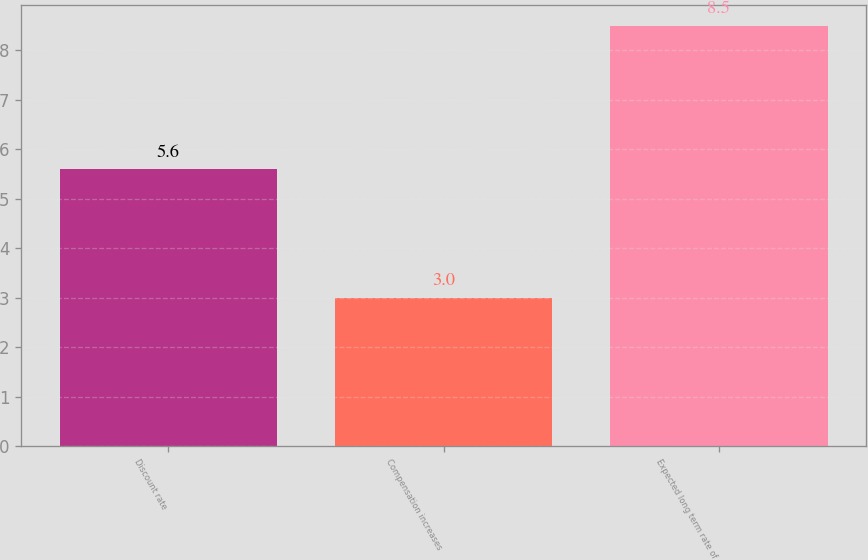<chart> <loc_0><loc_0><loc_500><loc_500><bar_chart><fcel>Discount rate<fcel>Compensation increases<fcel>Expected long term rate of<nl><fcel>5.6<fcel>3<fcel>8.5<nl></chart> 